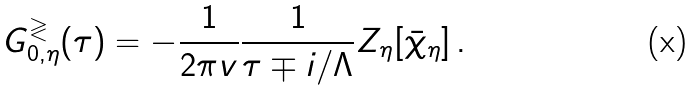Convert formula to latex. <formula><loc_0><loc_0><loc_500><loc_500>G _ { 0 , \eta } ^ { \gtrless } ( \tau ) = - \frac { 1 } { 2 \pi v } \frac { 1 } { \tau \mp i / \Lambda } Z _ { \eta } [ \bar { \chi } _ { \eta } ] \, .</formula> 